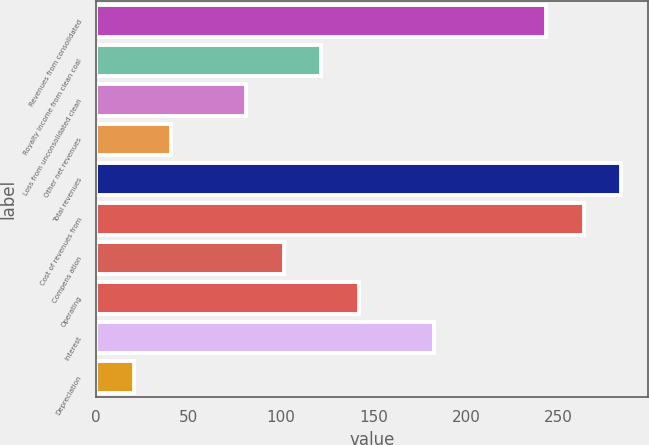<chart> <loc_0><loc_0><loc_500><loc_500><bar_chart><fcel>Revenues from consolidated<fcel>Royalty income from clean coal<fcel>Loss from unconsolidated clean<fcel>Other net revenues<fcel>Total revenues<fcel>Cost of revenues from<fcel>Compens ation<fcel>Operating<fcel>Interest<fcel>Depreciation<nl><fcel>243.51<fcel>121.77<fcel>81.19<fcel>40.61<fcel>284.09<fcel>263.8<fcel>101.48<fcel>142.06<fcel>182.64<fcel>20.32<nl></chart> 